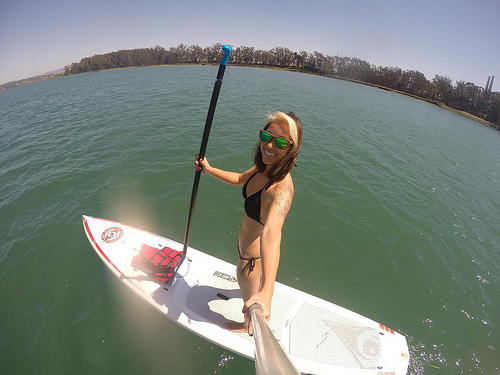<image>
Can you confirm if the woman is on the surf board? Yes. Looking at the image, I can see the woman is positioned on top of the surf board, with the surf board providing support. Is the board in the water? Yes. The board is contained within or inside the water, showing a containment relationship. 